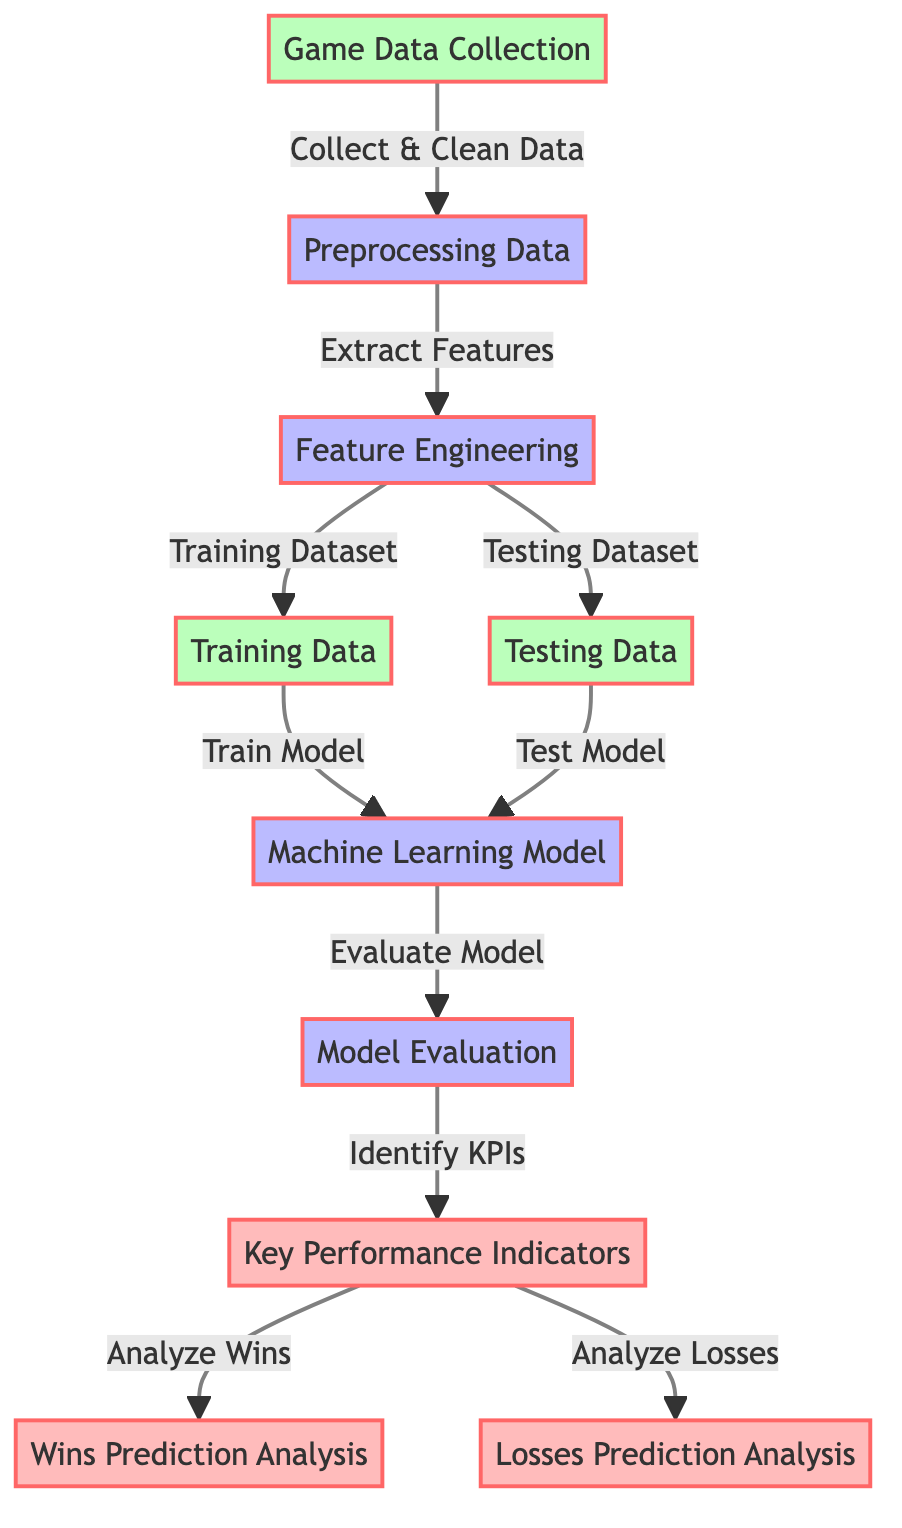What is the first node in the diagram? The first node is labeled "Game Data Collection." This is identified as it is the starting point of the flowchart, which indicates where the process begins.
Answer: Game Data Collection How many processing nodes are present in the diagram? The diagram shows four processing nodes: "Preprocessing Data," "Feature Engineering," "Machine Learning Model," and "Model Evaluation." We can count each of these nodes to arrive at the answer.
Answer: 4 What connects "Testing Dataset" and "Train Model"? The connection is labeled "Test Model." This can be seen in the flow of the diagram where the Testing Dataset flows into the Machine Learning Model node, which indicates that testing occurs after training.
Answer: Test Model Which node analyzes losses? The node labeled "Losses Prediction Analysis" is responsible for analyzing losses. This is determined by following the pathways from the "Key Performance Indicators" node; it branches out to this specific node.
Answer: Losses Prediction Analysis What do you obtain after "Evaluate Model"? After "Evaluate Model," the outcome is to "Identify KPIs." This can be tracked in the diagram as the next step following the evaluation phase.
Answer: Identify KPIs How does data flow from "Feature Engineering" to "Machine Learning Model"? The data flows from "Feature Engineering" to "Machine Learning Model" through the pathways labeled "Training Dataset" and "Testing Dataset." This shows that both datasets contribute to training the model.
Answer: Training Dataset and Testing Dataset What is the last step in the diagram? The last step is "Losses Prediction Analysis." In the flowchart, this occurs as a consequence of the earlier processes, specifically after analyzing Key Performance Indicators.
Answer: Losses Prediction Analysis Which two nodes are part of the analysis category? The nodes labeled "Key Performance Indicators" and "Wins Prediction Analysis" fall under the analysis category. This can be determined by examining the specific labeling and classification of the nodes shown in the diagram.
Answer: Key Performance Indicators and Wins Prediction Analysis How many total nodes are there in the diagram? There are ten total nodes in the diagram, which can be counted individually based on the components detailed in the flowchart.
Answer: 10 